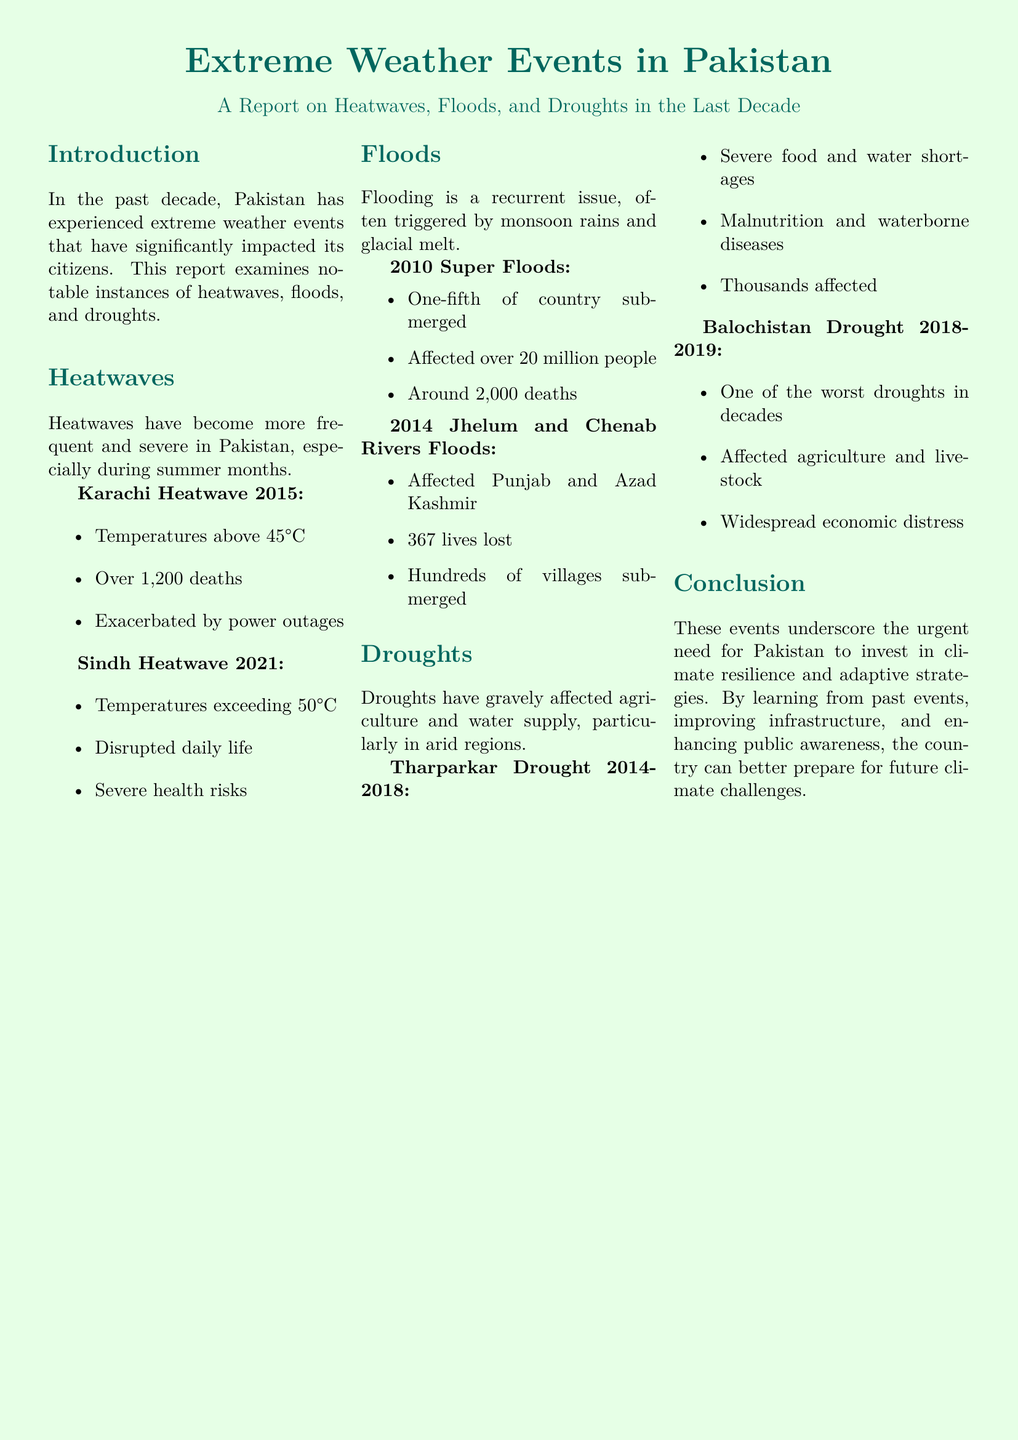What was the temperature during the Karachi heatwave in 2015? The document states that temperatures exceeded 45°C during the Karachi heatwave in 2015.
Answer: above 45°C How many deaths were reported due to the Sindh heatwave in 2021? The report does not provide an exact number of deaths but highlights severe health risks.
Answer: severe health risks What percentage of Pakistan was submerged during the 2010 super floods? The report indicates that one-fifth of the country was submerged during the 2010 floods.
Answer: one-fifth How many lives were lost during the 2014 floods in Punjab and Azad Kashmir? The document states that 367 lives were lost in the floods affecting Punjab and Azad Kashmir in 2014.
Answer: 367 lives What was a significant impact of the Tharparkar drought from 2014 to 2018? The Tharparkar drought resulted in severe food and water shortages affecting thousands of people.
Answer: food and water shortages What events triggered flooding in Pakistan? The report mentions that flooding is often triggered by monsoon rains and glacial melt.
Answer: monsoon rains and glacial melt What region of Pakistan was heavily affected by the 2018-2019 drought? The document specifically mentions Balochistan as one of the regions affected by the drought during that period.
Answer: Balochistan What does the conclusion of the report emphasize? The conclusion emphasizes the urgent need for Pakistan to invest in climate resilience and adaptive strategies.
Answer: climate resilience and adaptive strategies 